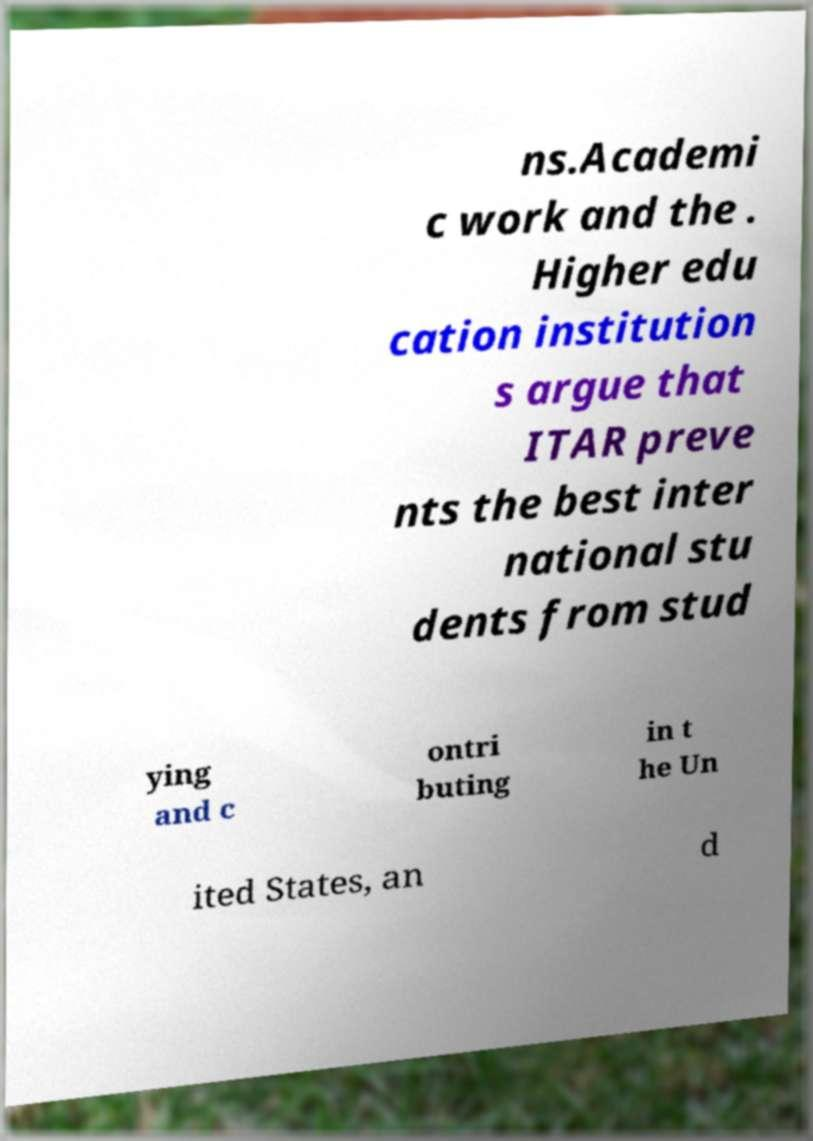What messages or text are displayed in this image? I need them in a readable, typed format. ns.Academi c work and the . Higher edu cation institution s argue that ITAR preve nts the best inter national stu dents from stud ying and c ontri buting in t he Un ited States, an d 